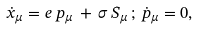<formula> <loc_0><loc_0><loc_500><loc_500>\dot { x } _ { \mu } = e \, p _ { \mu } \, + \, \sigma \, S _ { \mu } \, ; \, \dot { p } _ { \mu } = 0 ,</formula> 